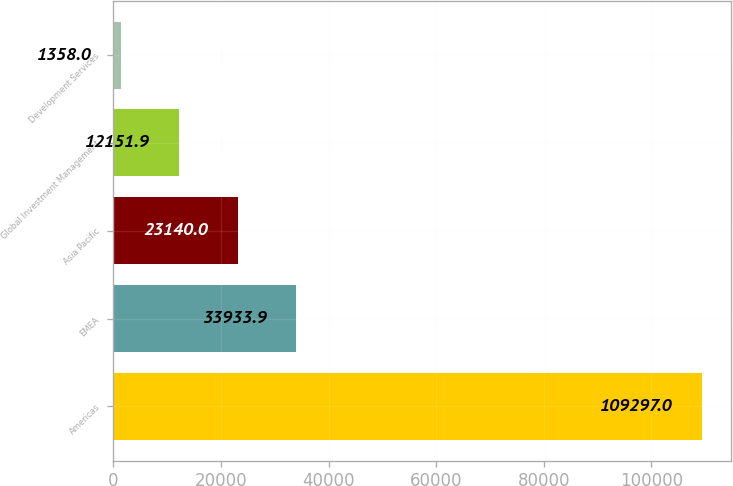Convert chart. <chart><loc_0><loc_0><loc_500><loc_500><bar_chart><fcel>Americas<fcel>EMEA<fcel>Asia Pacific<fcel>Global Investment Management<fcel>Development Services<nl><fcel>109297<fcel>33933.9<fcel>23140<fcel>12151.9<fcel>1358<nl></chart> 